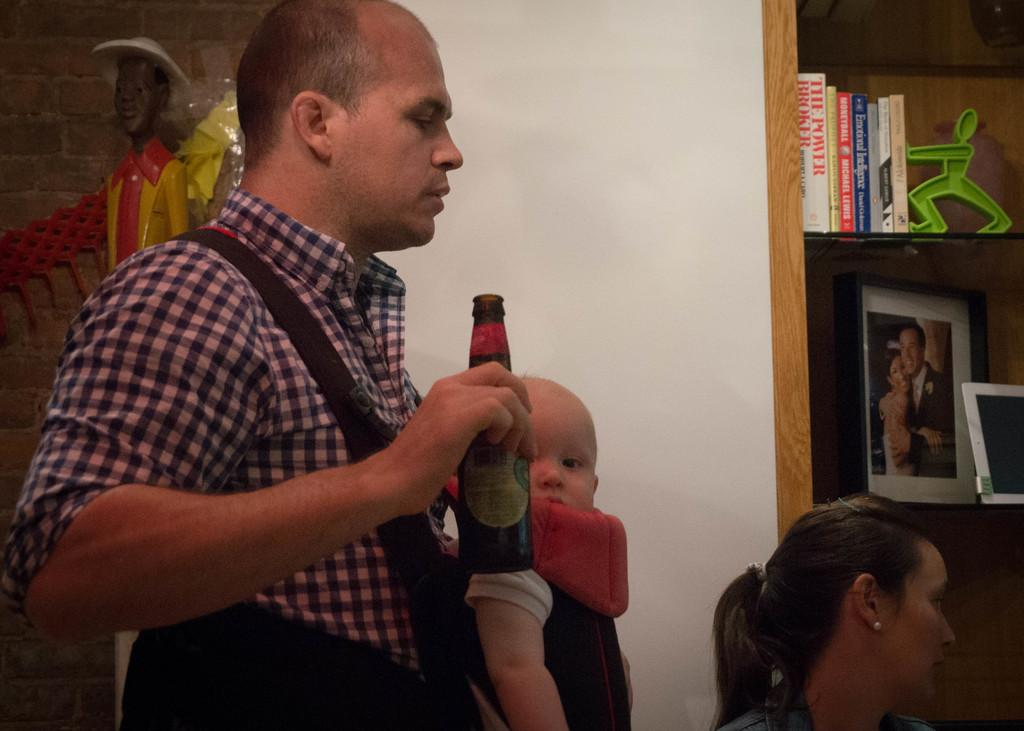Who is present in the image? There are people in the image. What is the man holding in his hand? The man is holding a bottle in his hand. What can be seen in the background of the image? There is a photo frame and books in the background of the image. What type of kite is being flown by the people in the image? There is no kite present in the image; it only shows people and a man holding a bottle. 